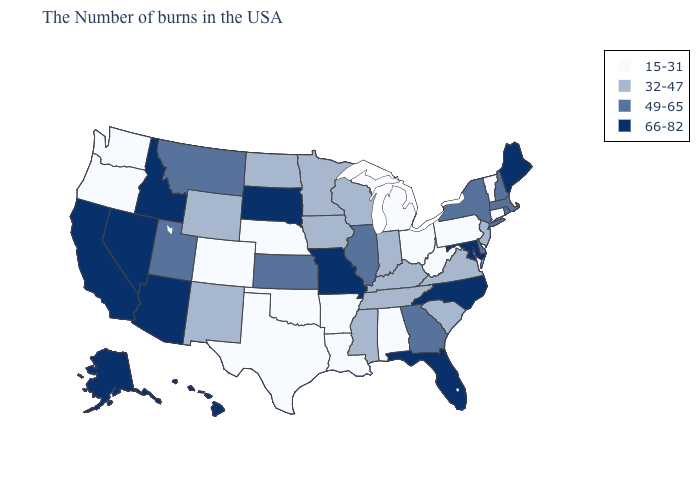Which states hav the highest value in the South?
Answer briefly. Maryland, North Carolina, Florida. Which states have the highest value in the USA?
Give a very brief answer. Maine, Maryland, North Carolina, Florida, Missouri, South Dakota, Arizona, Idaho, Nevada, California, Alaska, Hawaii. What is the value of Louisiana?
Quick response, please. 15-31. Name the states that have a value in the range 32-47?
Answer briefly. New Jersey, Virginia, South Carolina, Kentucky, Indiana, Tennessee, Wisconsin, Mississippi, Minnesota, Iowa, North Dakota, Wyoming, New Mexico. Does Alabama have the lowest value in the USA?
Give a very brief answer. Yes. Does Missouri have the highest value in the MidWest?
Quick response, please. Yes. Name the states that have a value in the range 49-65?
Keep it brief. Massachusetts, Rhode Island, New Hampshire, New York, Delaware, Georgia, Illinois, Kansas, Utah, Montana. What is the lowest value in the USA?
Write a very short answer. 15-31. Name the states that have a value in the range 32-47?
Keep it brief. New Jersey, Virginia, South Carolina, Kentucky, Indiana, Tennessee, Wisconsin, Mississippi, Minnesota, Iowa, North Dakota, Wyoming, New Mexico. Name the states that have a value in the range 15-31?
Quick response, please. Vermont, Connecticut, Pennsylvania, West Virginia, Ohio, Michigan, Alabama, Louisiana, Arkansas, Nebraska, Oklahoma, Texas, Colorado, Washington, Oregon. Name the states that have a value in the range 32-47?
Be succinct. New Jersey, Virginia, South Carolina, Kentucky, Indiana, Tennessee, Wisconsin, Mississippi, Minnesota, Iowa, North Dakota, Wyoming, New Mexico. How many symbols are there in the legend?
Be succinct. 4. Does the first symbol in the legend represent the smallest category?
Concise answer only. Yes. Name the states that have a value in the range 66-82?
Give a very brief answer. Maine, Maryland, North Carolina, Florida, Missouri, South Dakota, Arizona, Idaho, Nevada, California, Alaska, Hawaii. Does Kansas have the lowest value in the USA?
Give a very brief answer. No. 